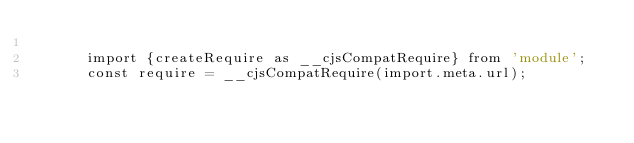<code> <loc_0><loc_0><loc_500><loc_500><_JavaScript_>
      import {createRequire as __cjsCompatRequire} from 'module';
      const require = __cjsCompatRequire(import.meta.url);</code> 